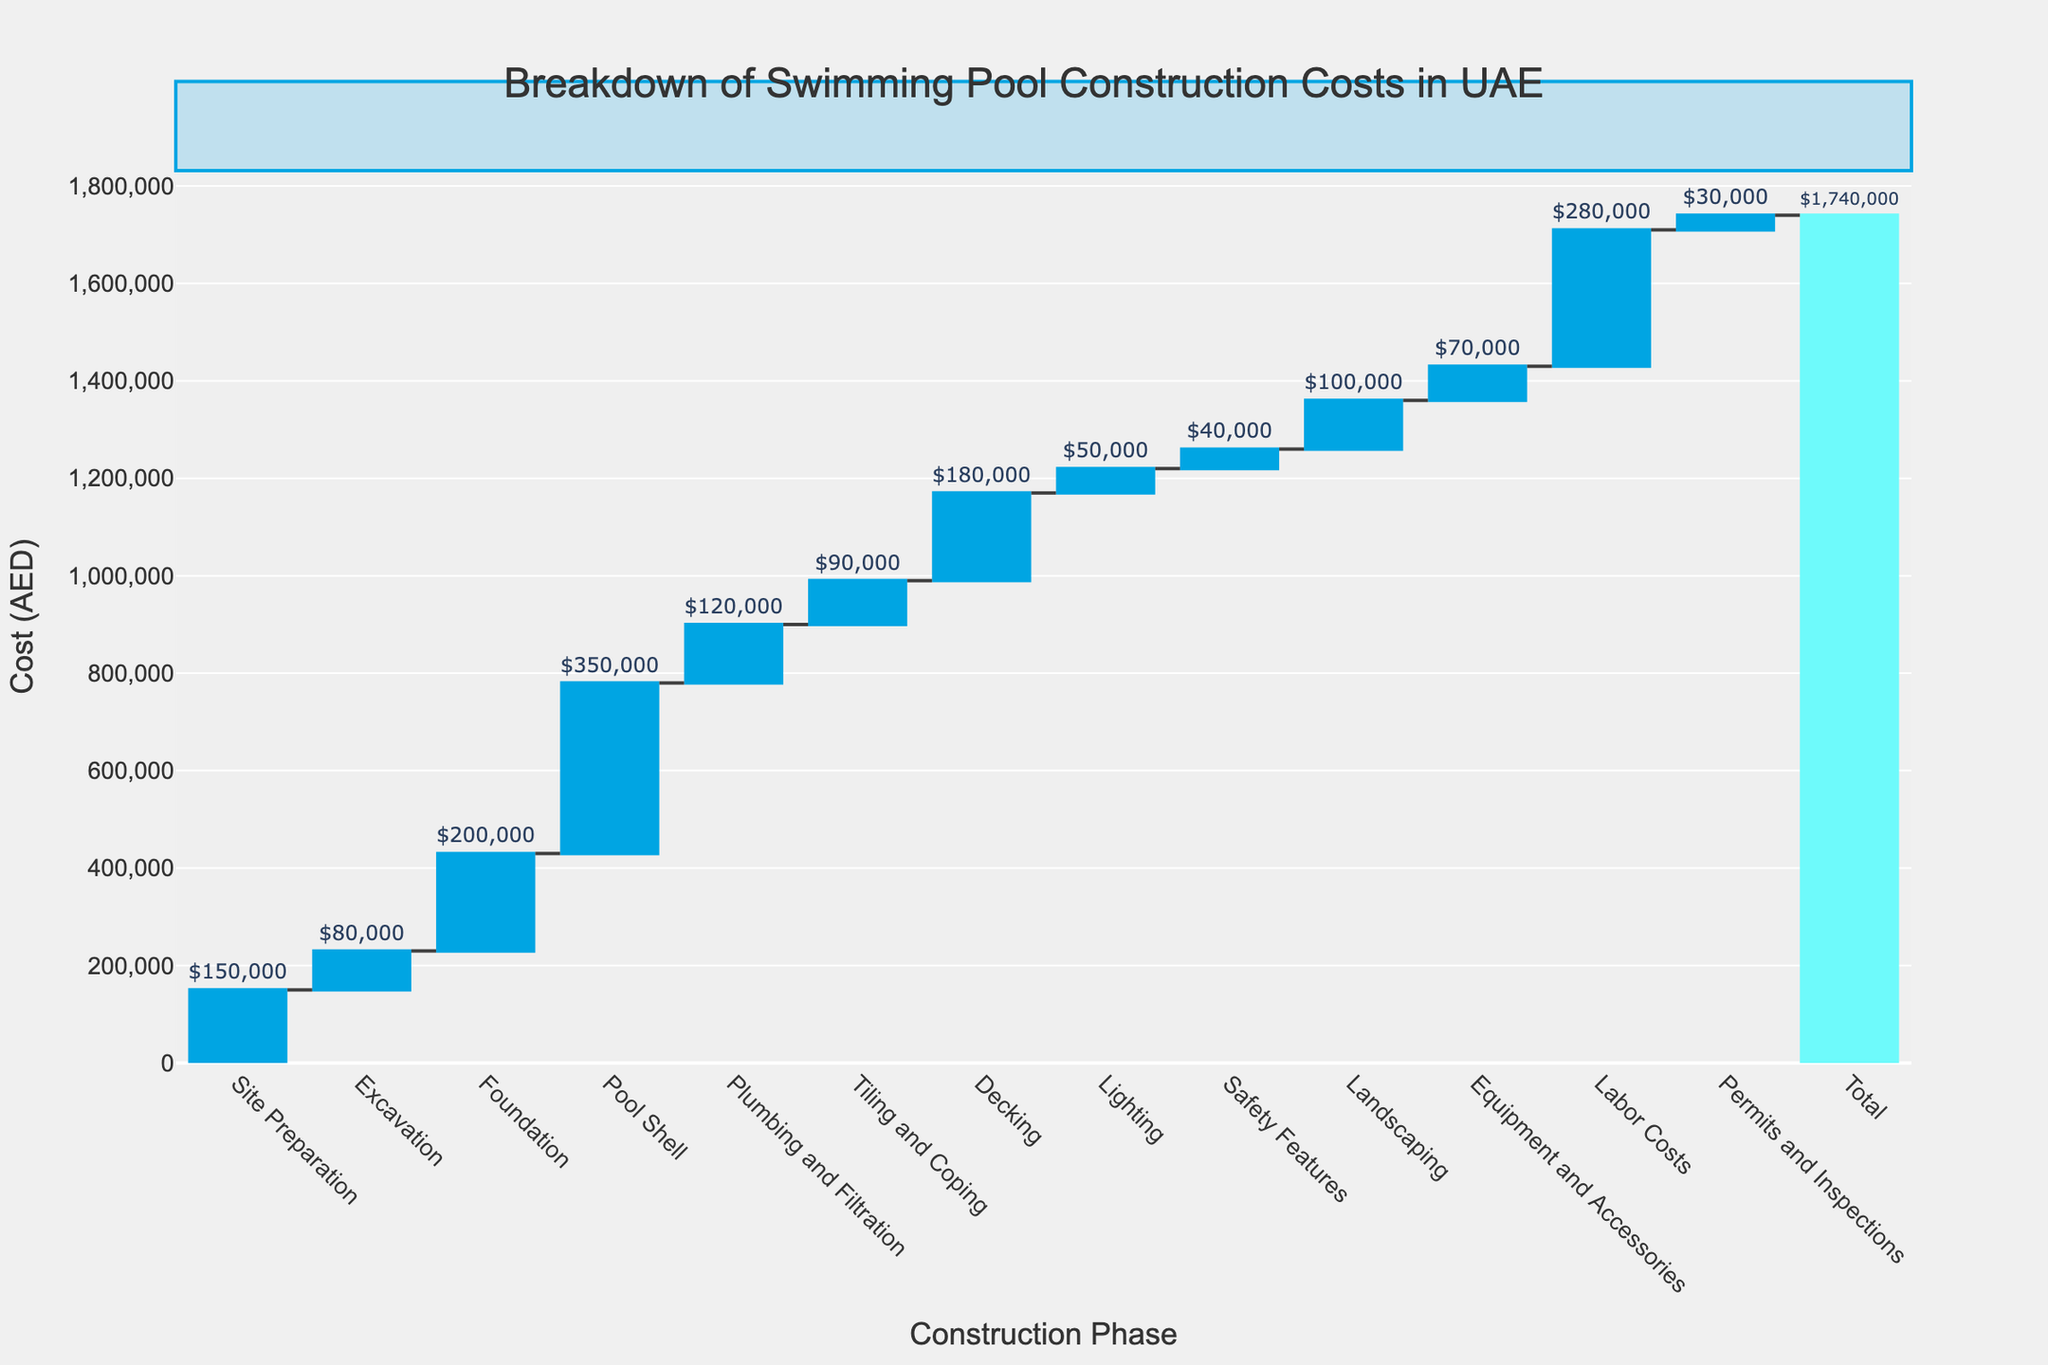How much does the Site Preparation phase cost? The cost for the Site Preparation is labeled directly in the waterfall chart.
Answer: 150,000 AED What is the title of the chart? The title is written at the top center of the chart.
Answer: Breakdown of Swimming Pool Construction Costs in UAE How many categories contribute to the total cost in the chart? There are vertical bars for each category listed from Site Preparation to Permits and Inspections, excluding the start and total categories. Counting these, there are 13.
Answer: 13 What phase contributes the highest cost to the total? The vertical bar with the highest value represents the highest cost, which is labeled 'Pool Shell'.
Answer: Pool Shell What is the total construction cost at the end? The final vertical bar labeled 'Total' shows the overall construction cost, which is the sum of all phases.
Answer: 1,740,000 AED What is the difference in cost between Excavation and Decking? The cost for Excavation is 80,000 AED, and for Decking, it is 180,000 AED. Subtracting these gives 180,000 - 80,000.
Answer: 100,000 AED How does the Decking cost compare to Tiling and Coping? Decking is 180,000 AED, and Tiling and Coping is 90,000 AED. Decking is double the cost of Tiling and Coping.
Answer: Double Which phase has the lowest cost and what is it? Comparing all the vertical bars, 'Permits and Inspections' has the shortest height, indicating the lowest cost.
Answer: Permits and Inspections, 30,000 AED How much do Plumbing and Filtration and Safety Features cost together? Plumbing and Filtration costs 120,000 AED and Safety Features cost 40,000 AED. Adding these gives 120,000 + 40,000.
Answer: 160,000 AED What percentage of the total cost is the Labor Costs? Labor Costs is 280,000 AED. The total cost is 1,740,000 AED. Dividing these and multiplying by 100 gives (280,000 / 1,740,000) * 100.
Answer: 16.1% 